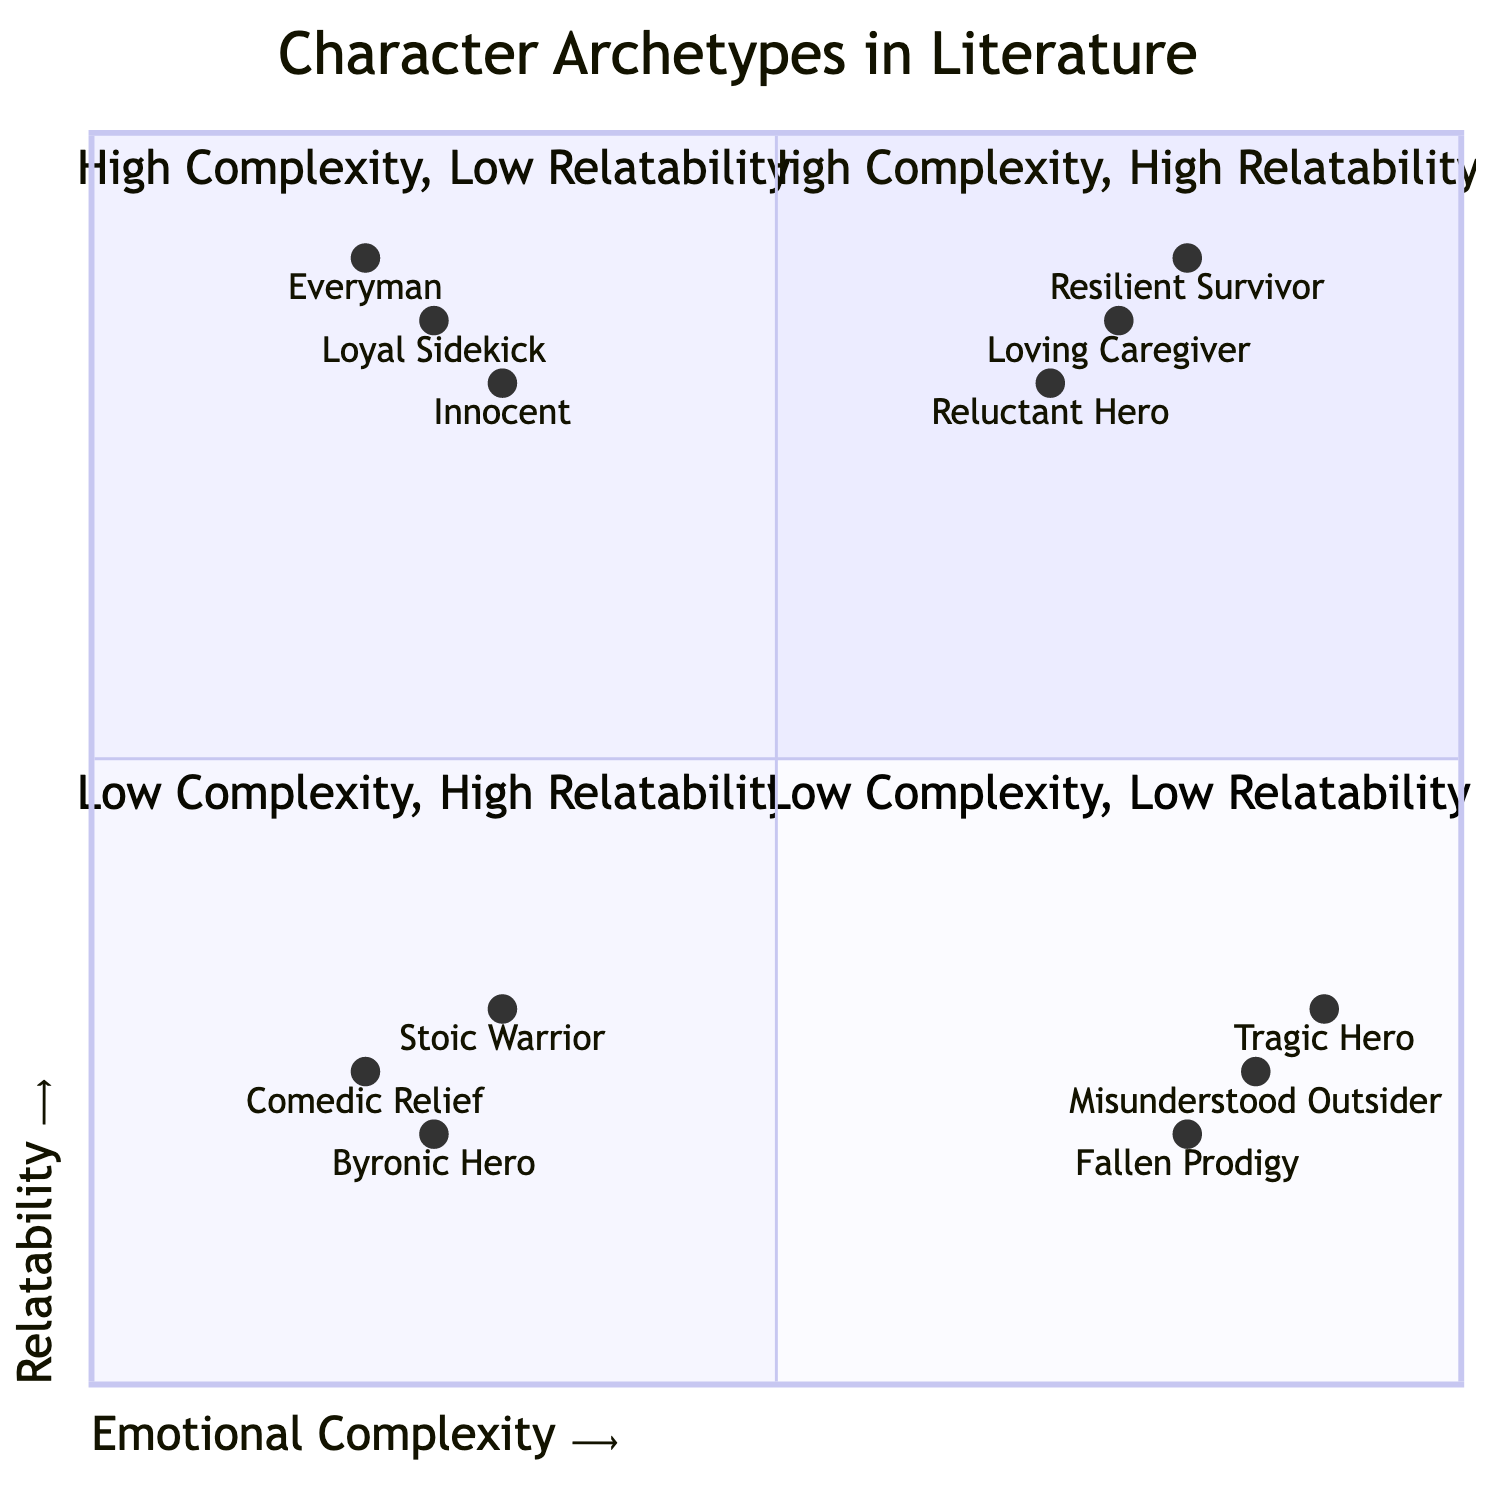What character archetype has the highest emotional complexity and relatability? The quadrant labeled "High Emotional Complexity, High Relatability" contains the character archetypes, and the example characters listed include Atticus Finch, Elizabeth Bennet, and Harry Potter.
Answer: The Resilient Survivor Which character archetype is an example of high emotional complexity but low relatability? In the quadrant "High Emotional Complexity, Low Relatability," the archetypes listed include The Tragic Hero, The Misunderstood Outsider, and The Fallen Prodigy. An example character is Jay Gatsby.
Answer: The Tragic Hero How many character archetypes are there in the quadrant with low emotional complexity and high relatability? The quadrant labeled "Low Emotional Complexity, High Relatability" features three character archetypes: The Everyman, The Loyal Sidekick, and The Innocent.
Answer: 3 What is the emotional complexity value of the Fallen Prodigy? The character archetype Fallen Prodigy is located in the quadrant "High Emotional Complexity, Low Relatability" with a corresponding emotional complexity value of 0.8.
Answer: 0.8 Which example character is associated with The Innocent archetype? The "Low Emotional Complexity, High Relatability" quadrant lists The Innocent archetype, with Scout Finch from 'To Kill a Mockingbird' as an associated example character.
Answer: Scout Finch How does the Reluctant Hero compare in relatability to The Loyal Sidekick? The Reluctant Hero has a relatability value of 0.8 while The Loyal Sidekick has a relatability value of 0.85 according to their positions in the chart, indicating that The Loyal Sidekick is slightly more relatable.
Answer: The Loyal Sidekick What archetype is categorized with low emotional complexity and provides comedic relief? The quadrant "Low Emotional Complexity, Low Relatability" includes the archetype Comedic Relief, which specifically serves the function of providing humor in a narrative.
Answer: Comedic Relief Which quadrant contains the character Raskolnikov? Raskolnikov is associated with the archetype of The Misunderstood Outsider, which is in the quadrant "High Emotional Complexity, Low Relatability."
Answer: High Emotional Complexity, Low Relatability 